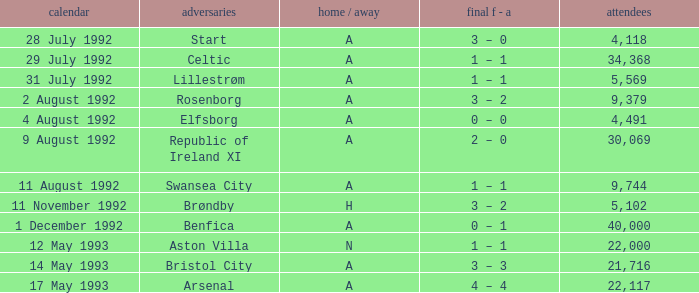What was the H/A on 29 july 1992? A. 